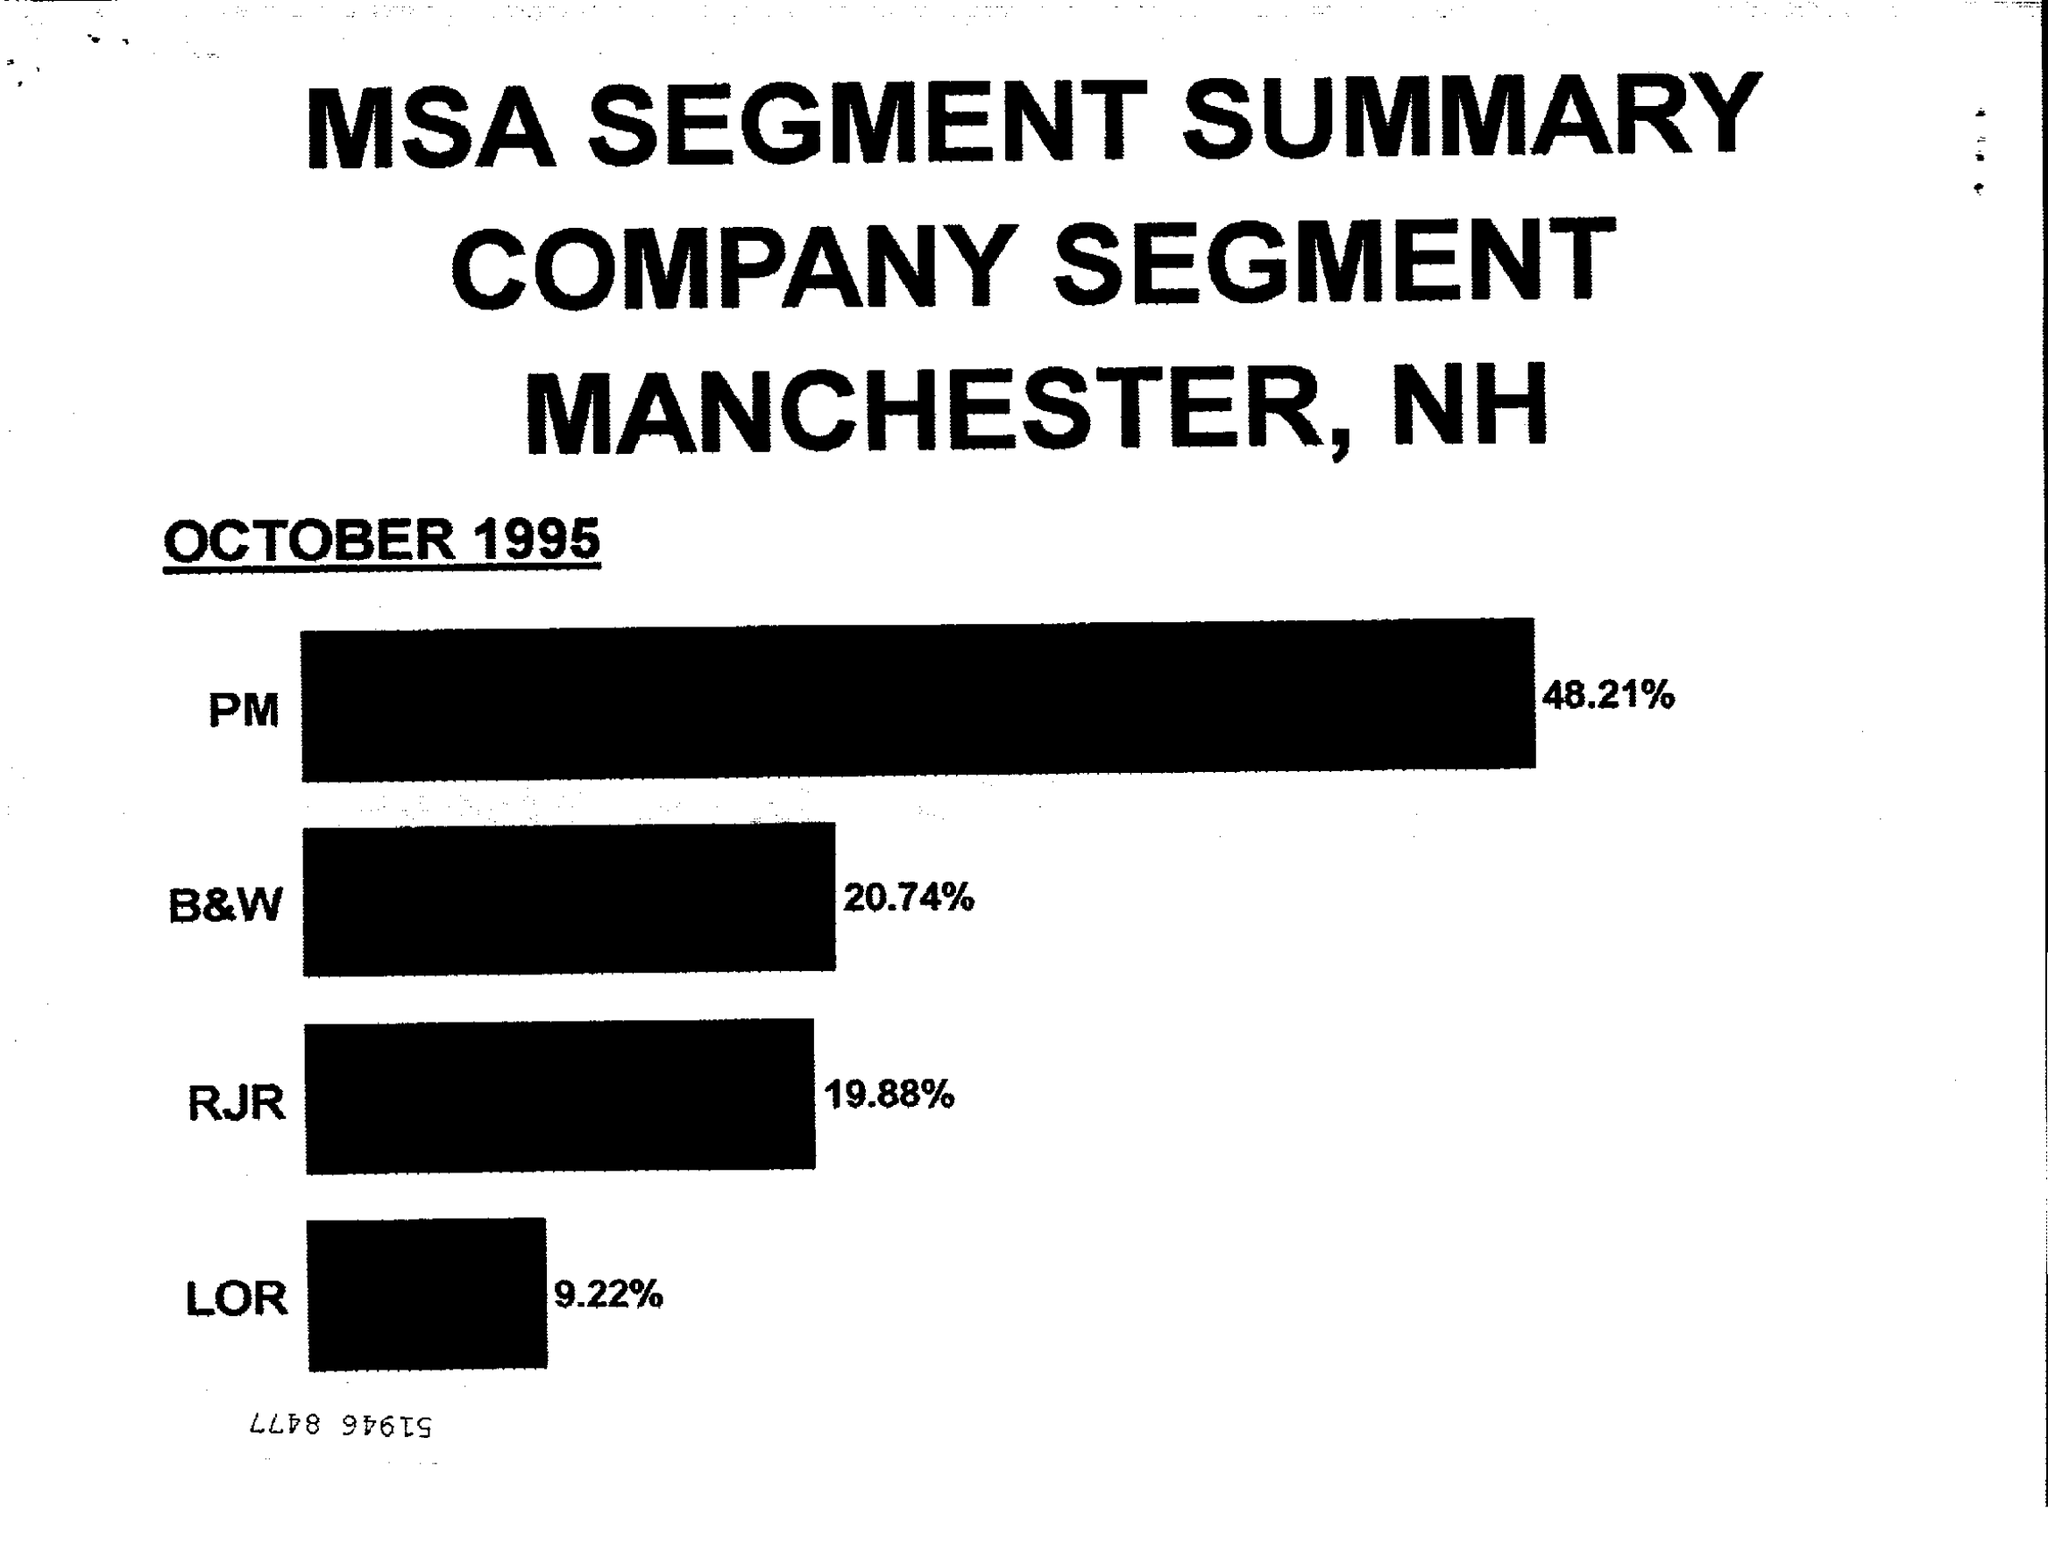Point out several critical features in this image. LOR's percentage is 9.22... RJR is currently at 19.88% 